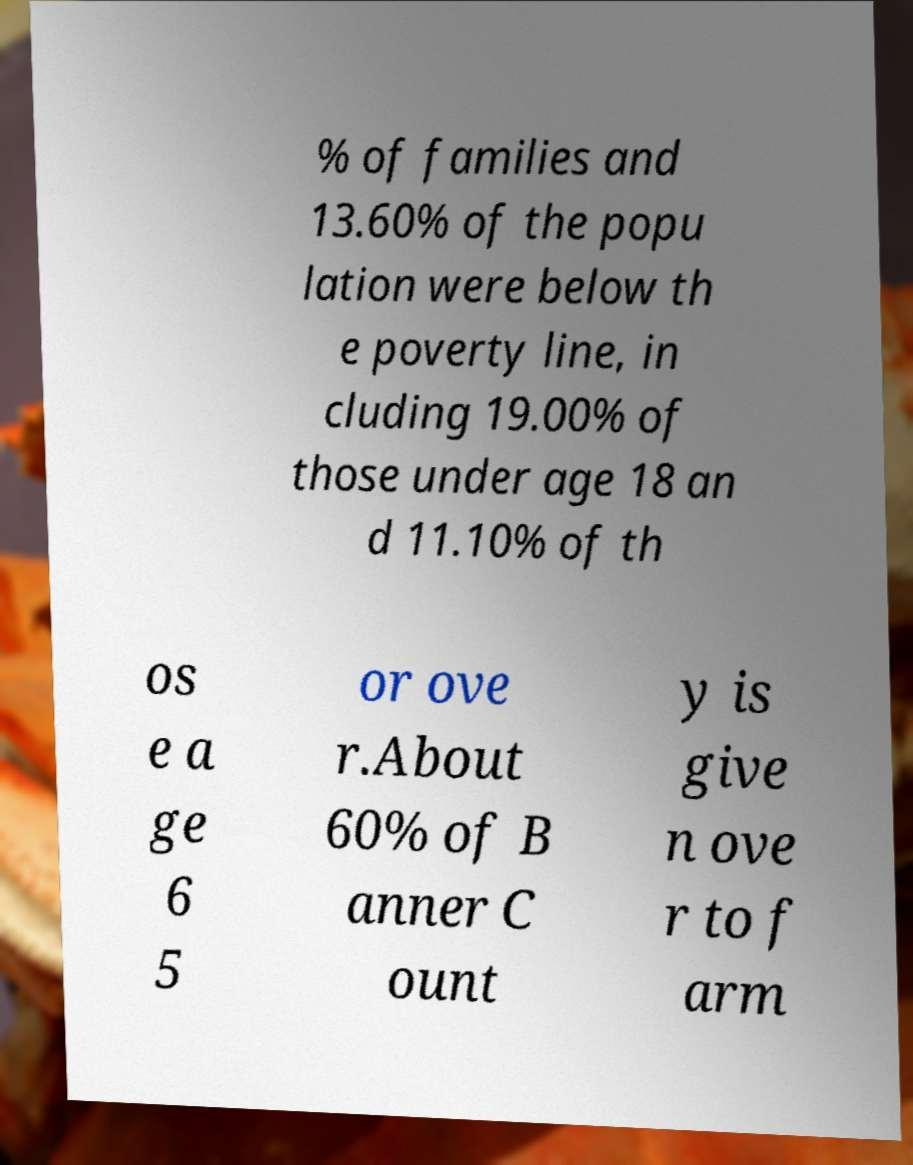Please identify and transcribe the text found in this image. % of families and 13.60% of the popu lation were below th e poverty line, in cluding 19.00% of those under age 18 an d 11.10% of th os e a ge 6 5 or ove r.About 60% of B anner C ount y is give n ove r to f arm 